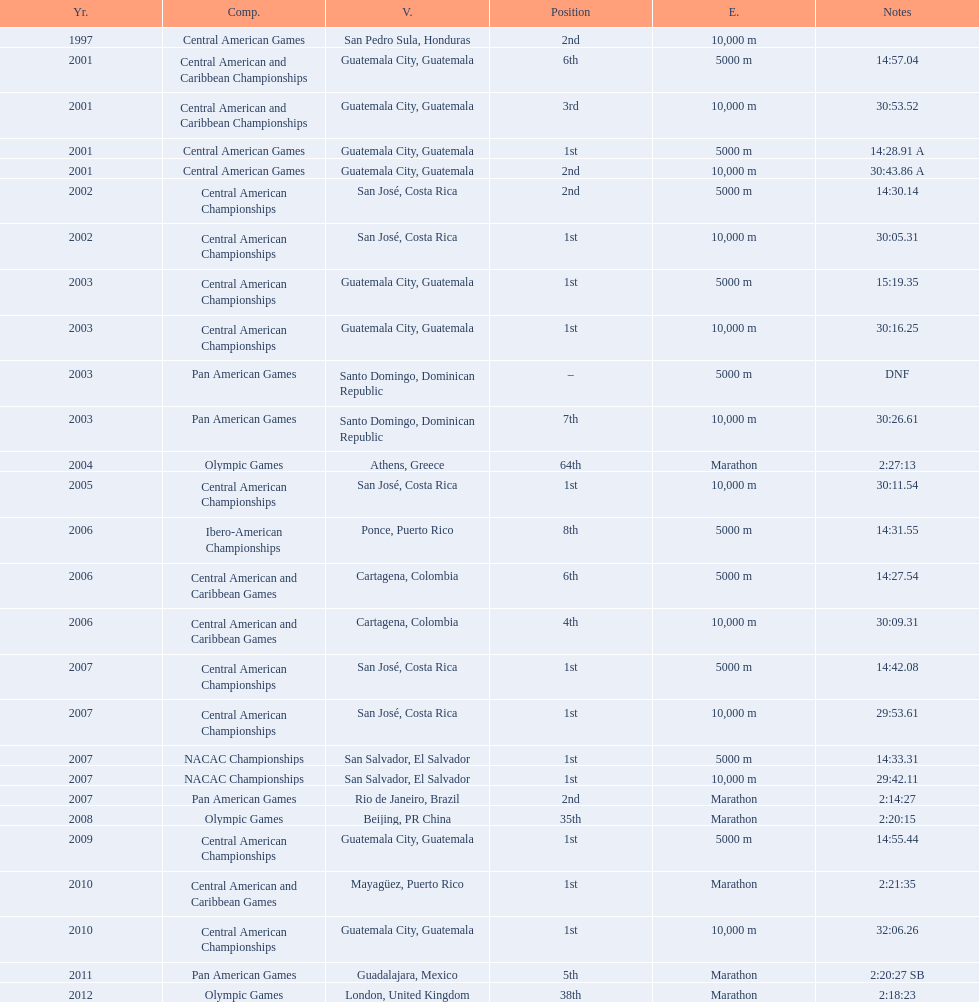What competition did this competitor compete at after participating in the central american games in 2001? Central American Championships. 